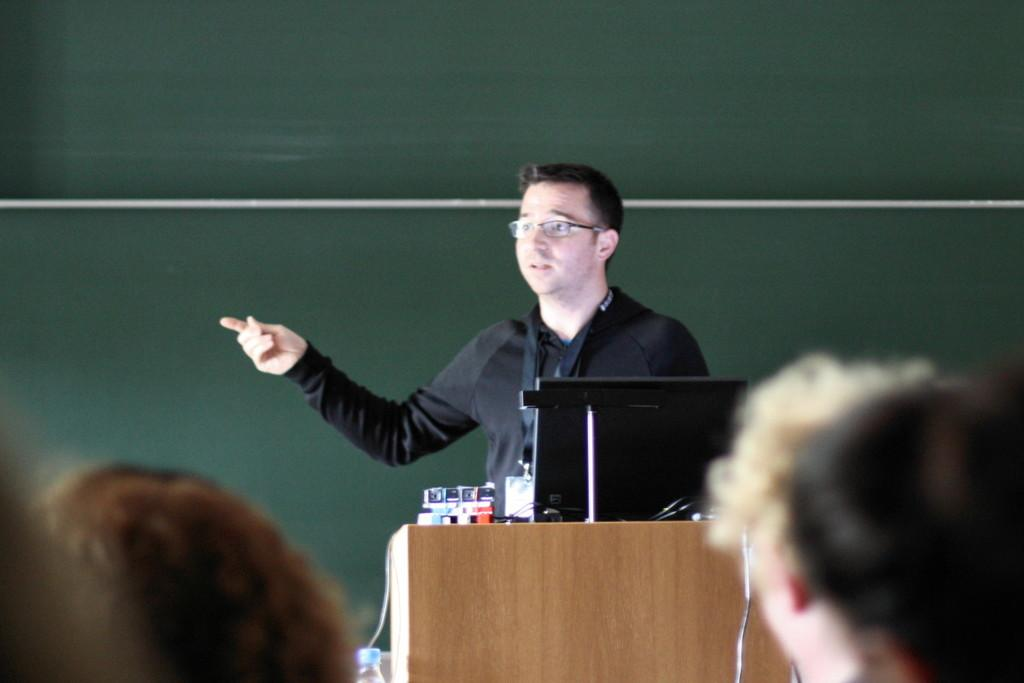What is the man in the image doing? The man is standing in front of a podium and talking. What is on the podium with the man? There is a laptop on the podium. Who is the man addressing in the image? There is a crowd in front of the man. What can be seen in the background of the image? There is a wall in the background. What type of operation is the man performing on the cat in the image? There is no cat present in the image, and the man is not performing any operation. 